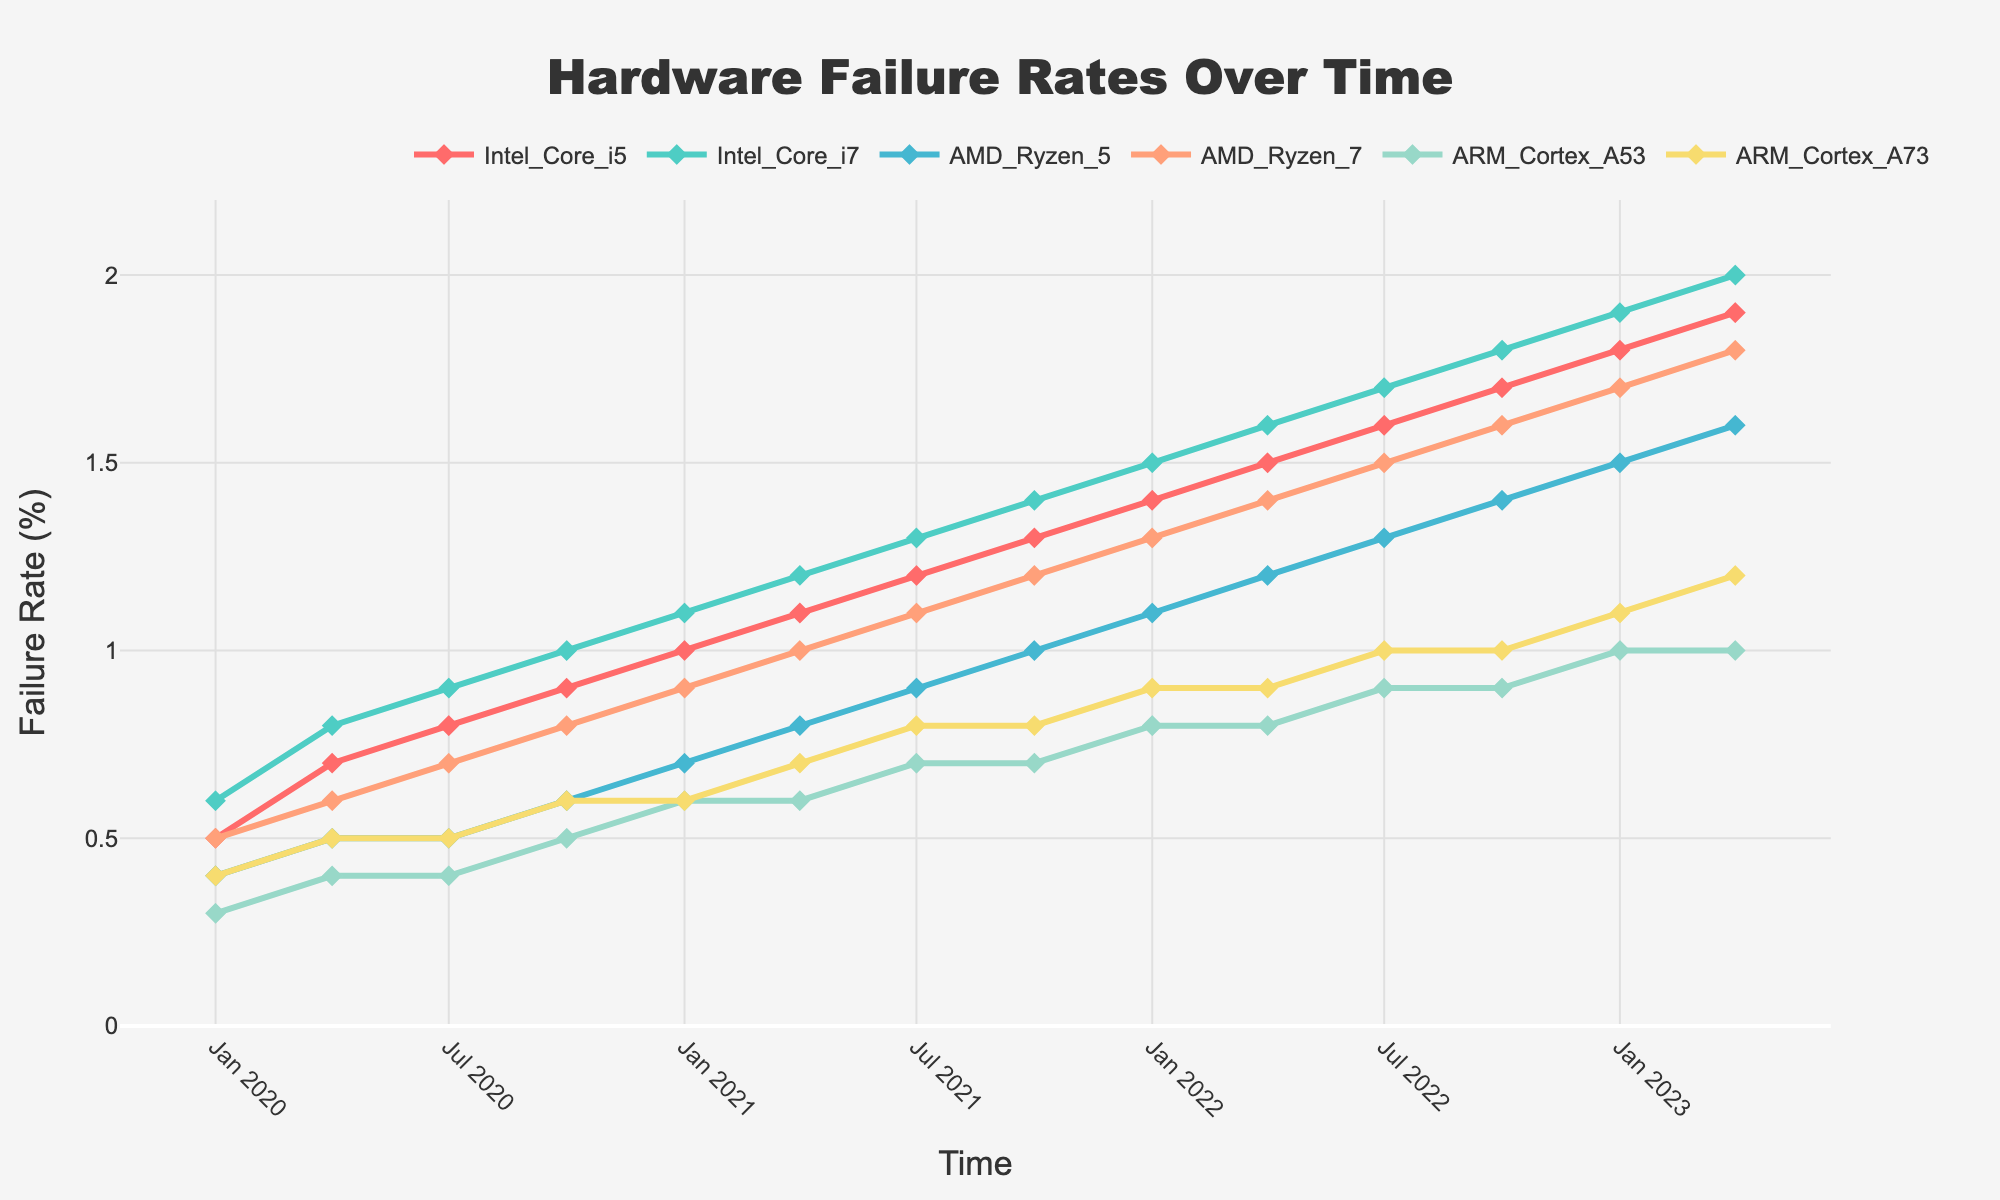What's the title of the plot? The title of the plot is displayed at the top and usually summarizes what the plot is about. Here, it would be read directly from the top of the figure.
Answer: Hardware Failure Rates Over Time What does the y-axis represent? The y-axis label is typically positioned on the vertical axis of the plot. Here, it denotes what the values plotted are measuring.
Answer: Failure Rate (%) How many different types of processors are being compared in the plot? By counting the number of different traces (lines + markers) on the plot, each representing a different processor, we can determine the number of different types of processors.
Answer: 6 Which processor has the highest failure rate in 2020-Q1? By locating 2020-Q1 on the x-axis and observing the failure rates (y-values) for each processor during this time period, we identify the processor with the highest failure rate.
Answer: Intel Core i7 How does the failure rate of Intel Core i5 compare to AMD Ryzen 5 in 2021-Q2? By locating 2021-Q2 on the x-axis and comparing the y-values for Intel Core i5 and AMD Ryzen 5, we can see which one has a higher or lower failure rate.
Answer: Intel Core i5 is higher than AMD Ryzen 5 What is the average failure rate of ARM Cortex A53 from 2020-Q1 to 2021-Q4? To find the average, sum the failure rates of ARM Cortex A53 for the quarters between 2020-Q1 and 2021-Q4 and divide by the number of data points in that range. For ARM Cortex A53, the rates are 0.3, 0.4, 0.4, 0.5, 0.6, 0.6, 0.7, and 0.7. Hence the average is (0.3+0.4+0.4+0.5+0.6+0.6+0.7+0.7)/8 = 0.525.
Answer: 0.525 Which processor shows the most consistent increase in failure rates over time? By observing the trend lines for each processor, the one with the most consistent upward slope without sharp increases or decreases shows the most consistent growth.
Answer: Intel Core i7 What is the difference in failure rates between the highest and lowest processors in 2022-Q4? Locate 2022-Q4 on the x-axis and identify the highest and lowest failure rates among all processors. Subtract the lowest from the highest value. The highest is Intel Core i7 at 1.8, and the lowest is ARM Cortex A53 at 0.9. Thus, the difference is 1.8 - 0.9 = 0.9.
Answer: 0.9 Which processor's failure rate increased the most from 2021-Q1 to 2023-Q2? Compare the failure rates of each processor at 2021-Q1 and at 2023-Q2 by subtracting the earlier value from the later value for each processor to identify the one with the greatest increase.
Answer: Intel Core i7 increased the most (from 1.1 to 2.0, a difference of 0.9) 